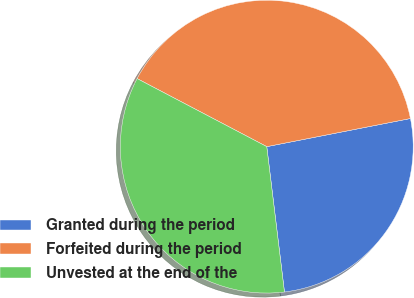Convert chart to OTSL. <chart><loc_0><loc_0><loc_500><loc_500><pie_chart><fcel>Granted during the period<fcel>Forfeited during the period<fcel>Unvested at the end of the<nl><fcel>26.15%<fcel>39.23%<fcel>34.62%<nl></chart> 